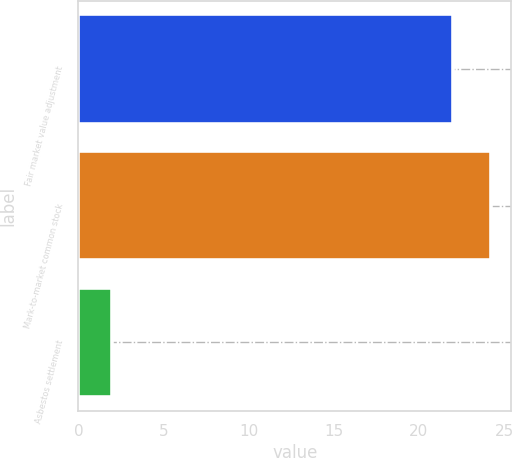Convert chart. <chart><loc_0><loc_0><loc_500><loc_500><bar_chart><fcel>Fair market value adjustment<fcel>Mark-to-market common stock<fcel>Asbestos settlement<nl><fcel>22<fcel>24.2<fcel>2<nl></chart> 